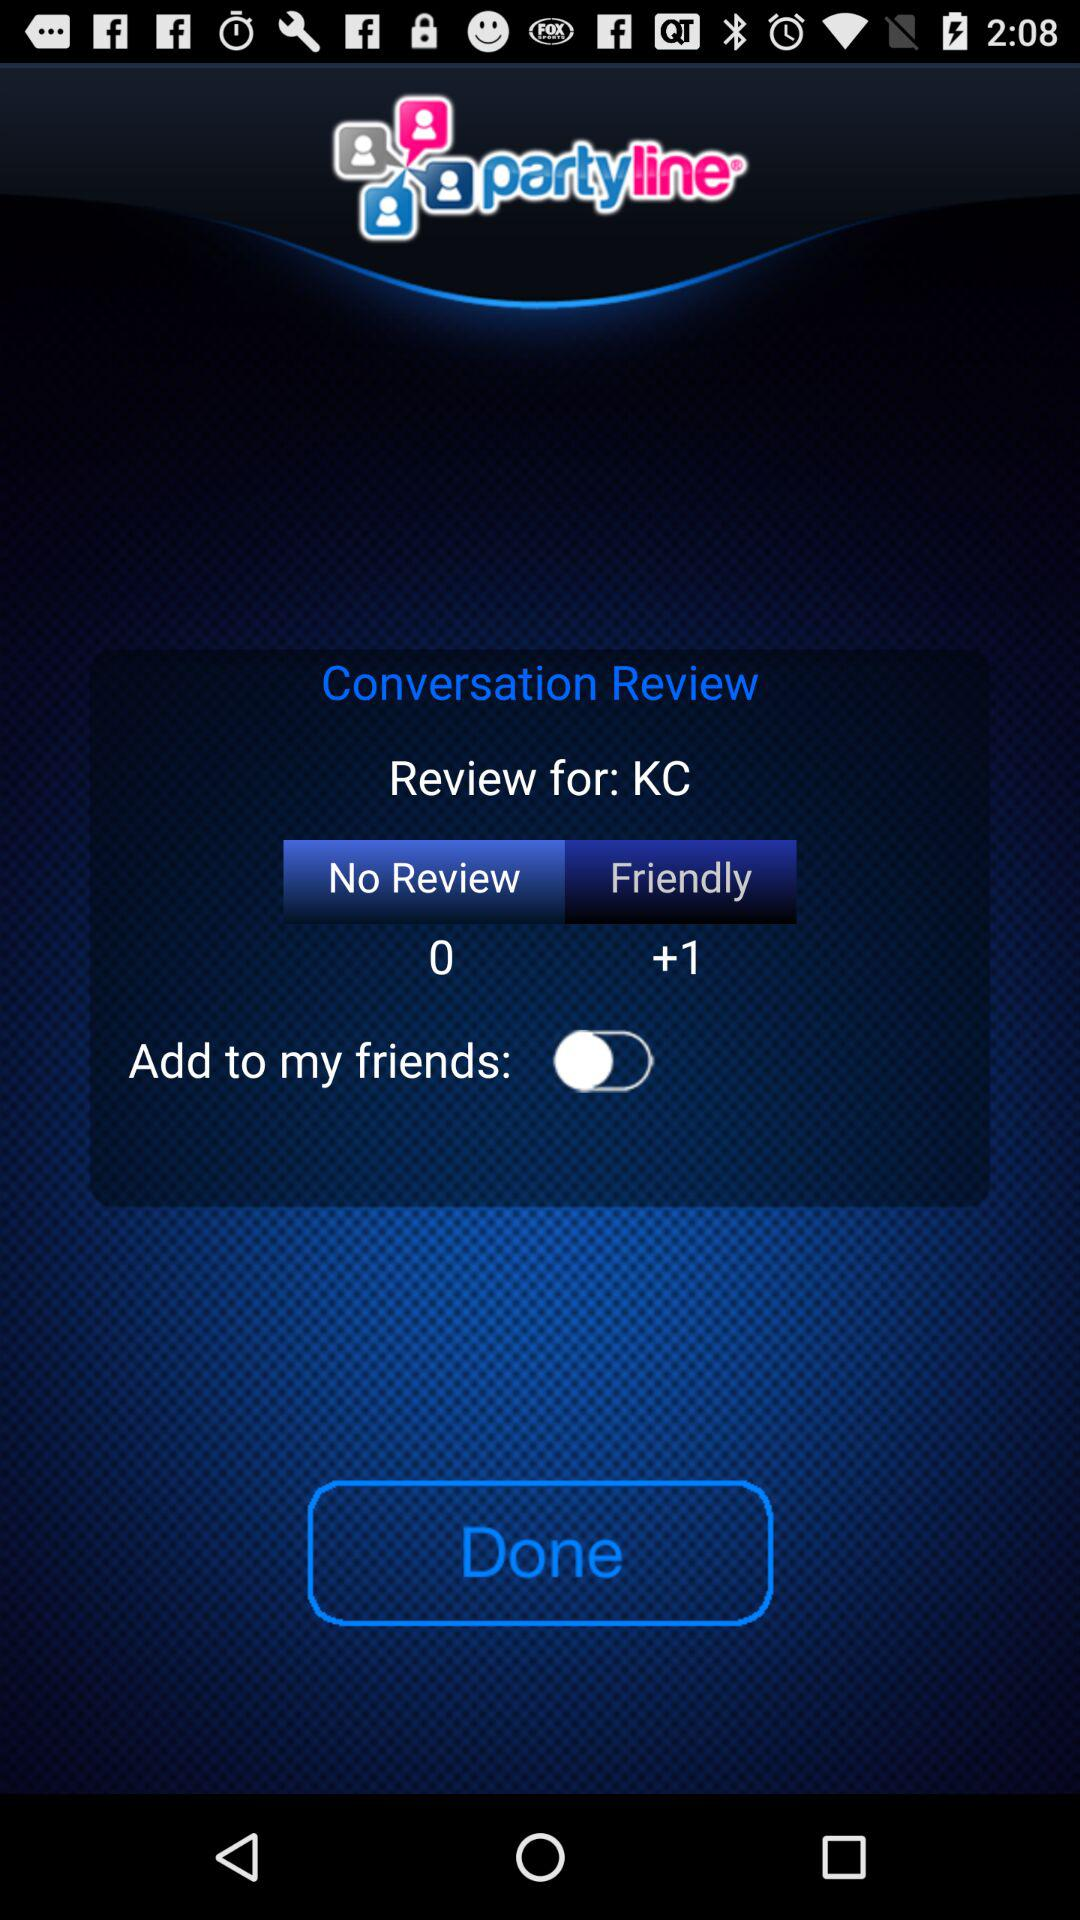How many "Friendly" are there? There is a +1 friendly. 